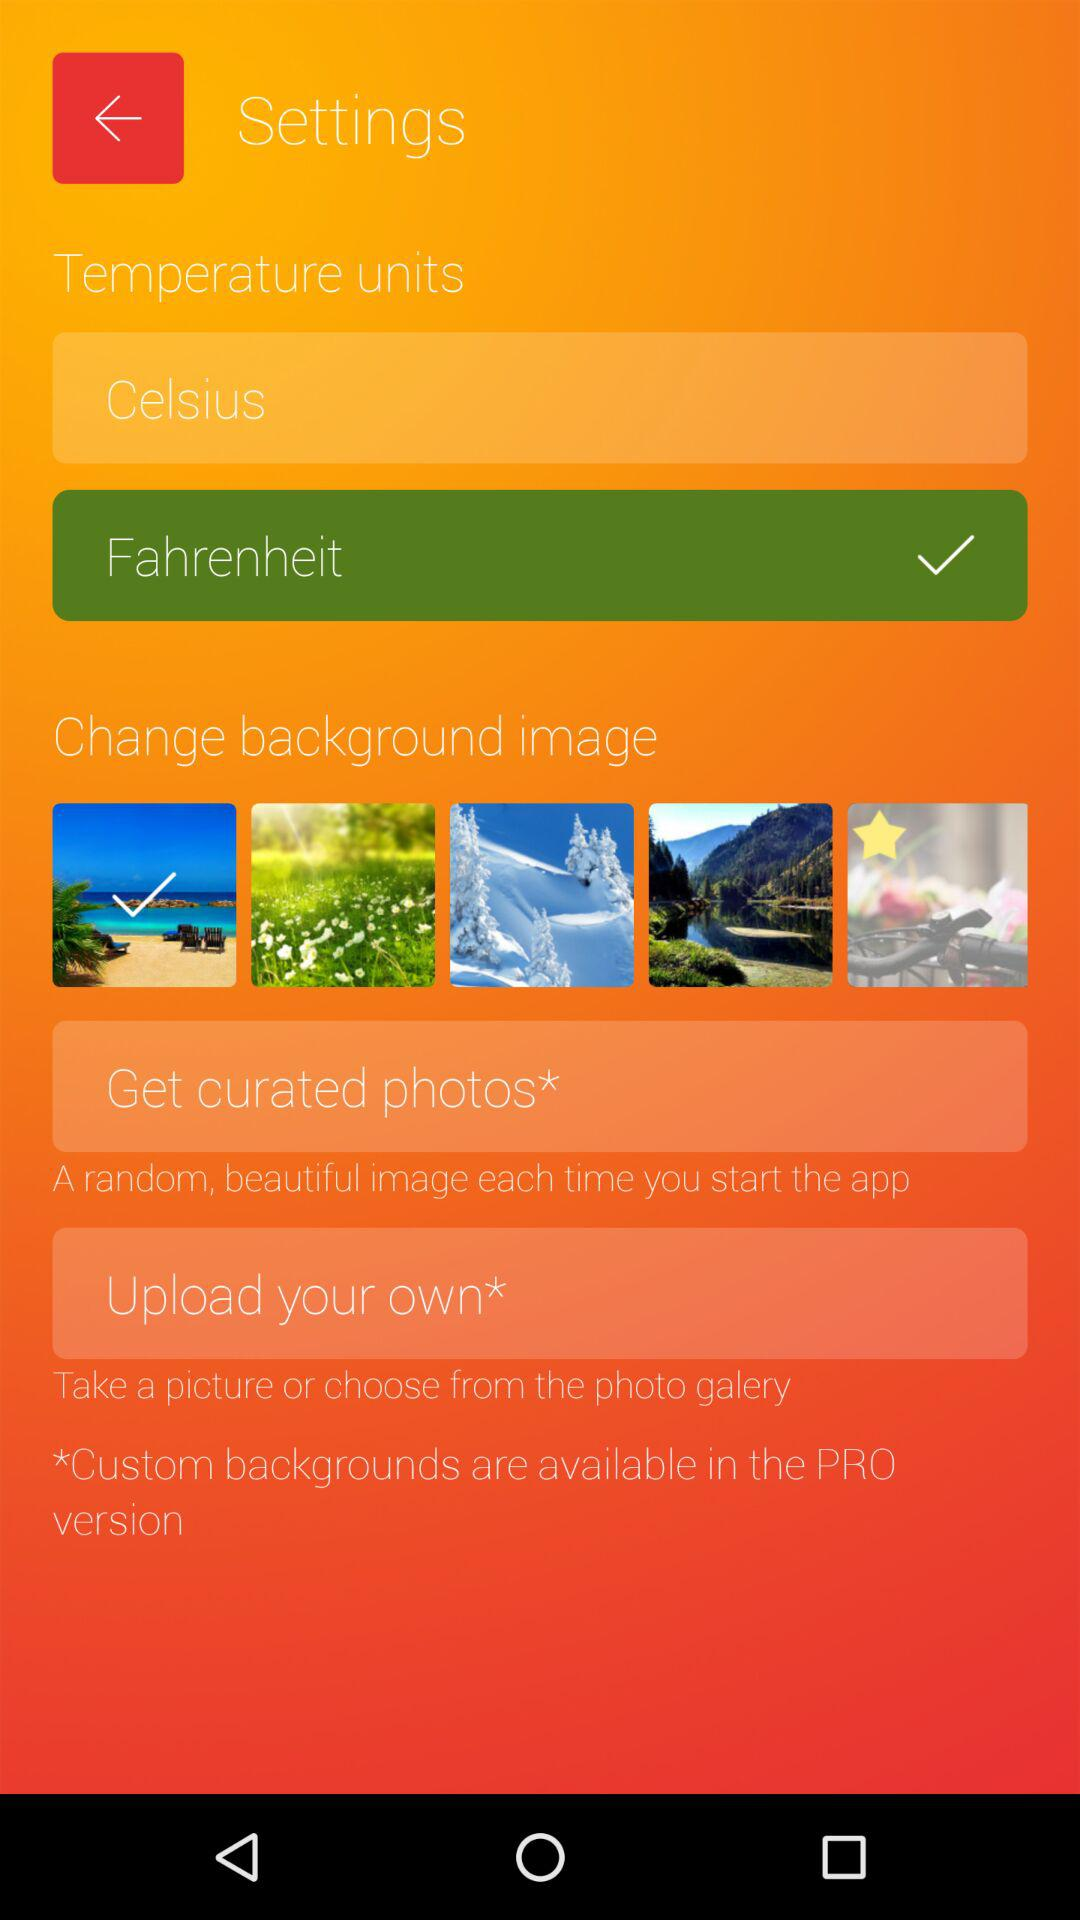What are the temperature units available? The temperature units available are Celsius and Fahrenheit. 